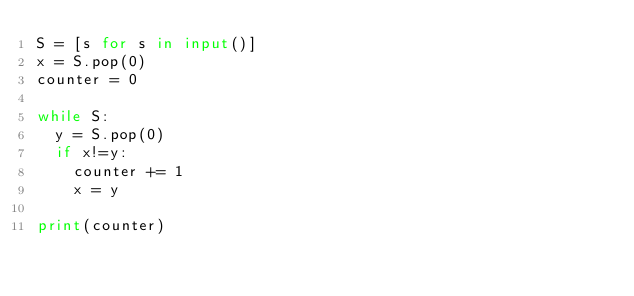<code> <loc_0><loc_0><loc_500><loc_500><_Python_>S = [s for s in input()]
x = S.pop(0)
counter = 0 

while S:
  y = S.pop(0)
  if x!=y:
    counter += 1
    x = y

print(counter)</code> 